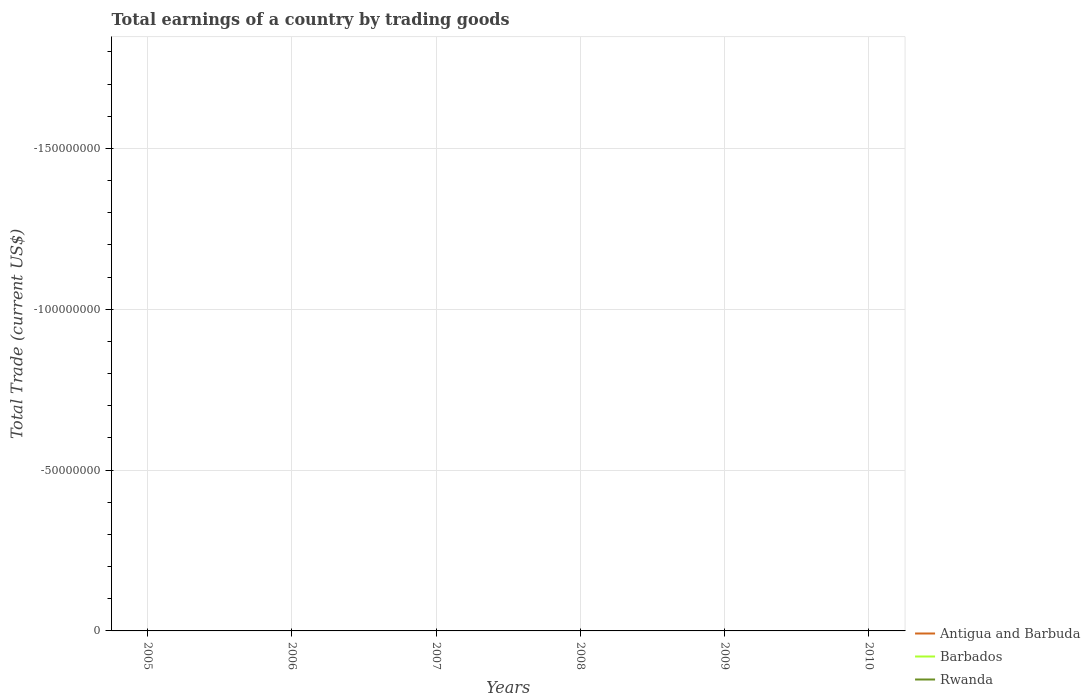How many different coloured lines are there?
Provide a short and direct response. 0. Does the line corresponding to Barbados intersect with the line corresponding to Antigua and Barbuda?
Offer a terse response. No. What is the difference between the highest and the lowest total earnings in Barbados?
Provide a succinct answer. 0. How are the legend labels stacked?
Ensure brevity in your answer.  Vertical. What is the title of the graph?
Your response must be concise. Total earnings of a country by trading goods. Does "Curacao" appear as one of the legend labels in the graph?
Your answer should be very brief. No. What is the label or title of the Y-axis?
Offer a terse response. Total Trade (current US$). What is the Total Trade (current US$) of Antigua and Barbuda in 2005?
Your answer should be very brief. 0. What is the Total Trade (current US$) of Barbados in 2005?
Your response must be concise. 0. What is the Total Trade (current US$) in Rwanda in 2005?
Your response must be concise. 0. What is the Total Trade (current US$) in Antigua and Barbuda in 2007?
Offer a very short reply. 0. What is the Total Trade (current US$) in Barbados in 2008?
Offer a very short reply. 0. What is the Total Trade (current US$) of Antigua and Barbuda in 2009?
Make the answer very short. 0. What is the Total Trade (current US$) in Rwanda in 2009?
Your response must be concise. 0. What is the Total Trade (current US$) in Antigua and Barbuda in 2010?
Your answer should be very brief. 0. What is the Total Trade (current US$) of Barbados in 2010?
Keep it short and to the point. 0. What is the total Total Trade (current US$) of Antigua and Barbuda in the graph?
Give a very brief answer. 0. What is the total Total Trade (current US$) of Barbados in the graph?
Keep it short and to the point. 0. What is the total Total Trade (current US$) in Rwanda in the graph?
Your answer should be compact. 0. What is the average Total Trade (current US$) in Rwanda per year?
Provide a succinct answer. 0. 